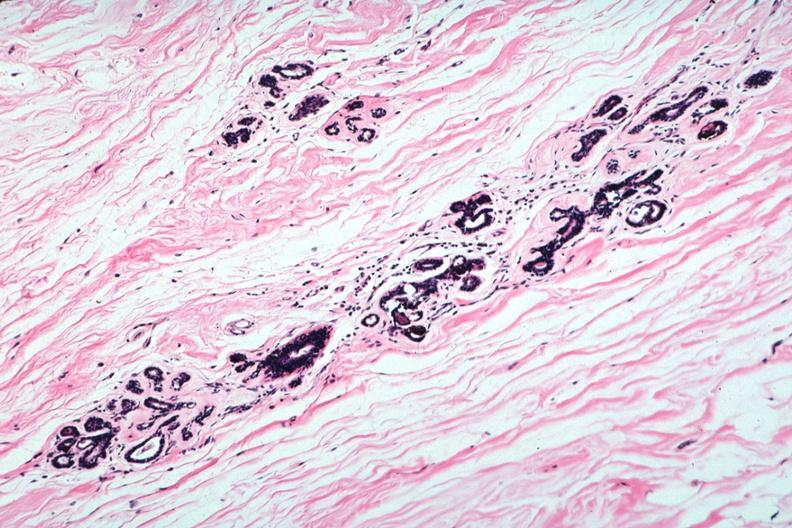s anencephaly present?
Answer the question using a single word or phrase. No 